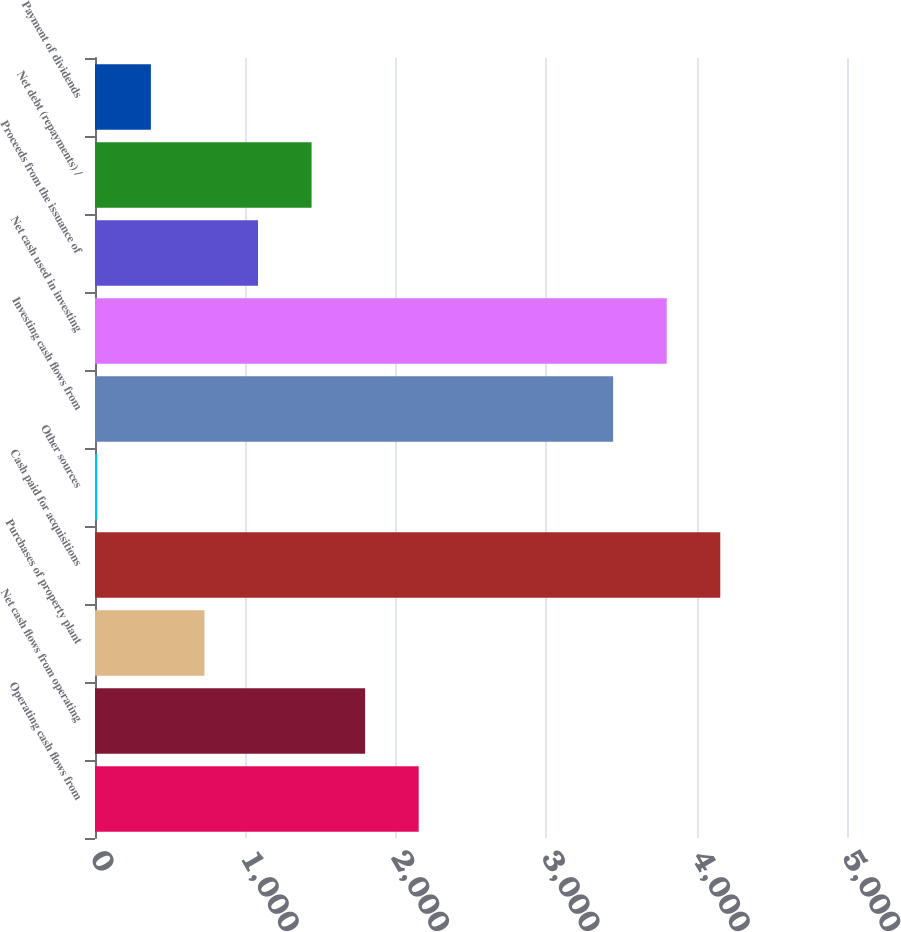<chart> <loc_0><loc_0><loc_500><loc_500><bar_chart><fcel>Operating cash flows from<fcel>Net cash flows from operating<fcel>Purchases of property plant<fcel>Cash paid for acquisitions<fcel>Other sources<fcel>Investing cash flows from<fcel>Net cash used in investing<fcel>Proceeds from the issuance of<fcel>Net debt (repayments) /<fcel>Payment of dividends<nl><fcel>2152.16<fcel>1796.05<fcel>727.72<fcel>4157.32<fcel>15.5<fcel>3445.1<fcel>3801.21<fcel>1083.83<fcel>1439.94<fcel>371.61<nl></chart> 